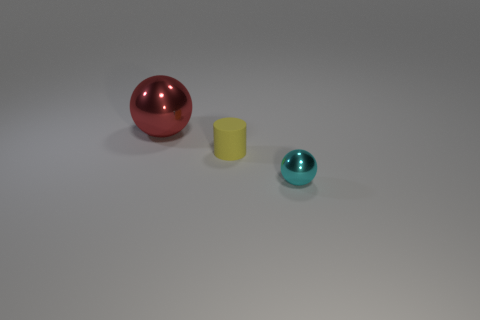Is the size of the cyan metal object the same as the yellow rubber cylinder?
Offer a terse response. Yes. What shape is the yellow rubber object that is right of the metallic object left of the shiny sphere that is to the right of the red sphere?
Your response must be concise. Cylinder. What is the color of the big shiny object that is the same shape as the tiny shiny thing?
Your response must be concise. Red. What is the size of the thing that is both on the left side of the tiny cyan ball and right of the red thing?
Your answer should be compact. Small. There is a cyan metal ball that is in front of the sphere behind the yellow cylinder; how many big red balls are right of it?
Keep it short and to the point. 0. What number of big objects are matte cylinders or cyan spheres?
Provide a succinct answer. 0. Do the ball in front of the large metal sphere and the red thing have the same material?
Provide a short and direct response. Yes. There is a thing that is behind the small object behind the ball to the right of the red sphere; what is its material?
Offer a very short reply. Metal. Are there any other things that have the same size as the yellow matte thing?
Give a very brief answer. Yes. How many shiny things are either small yellow objects or large red spheres?
Provide a short and direct response. 1. 